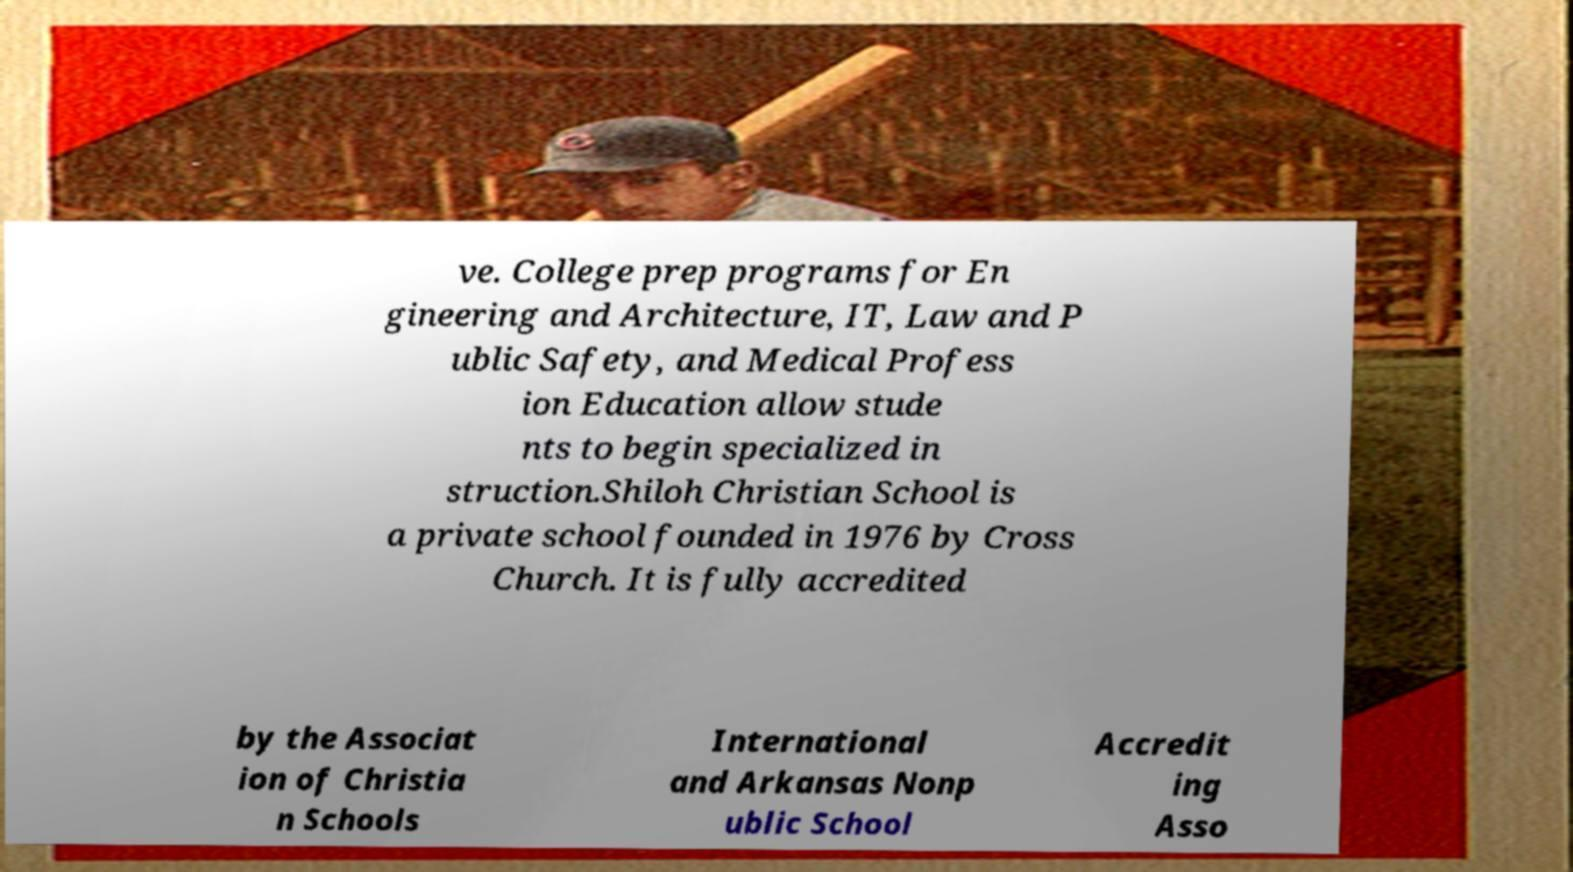Could you extract and type out the text from this image? ve. College prep programs for En gineering and Architecture, IT, Law and P ublic Safety, and Medical Profess ion Education allow stude nts to begin specialized in struction.Shiloh Christian School is a private school founded in 1976 by Cross Church. It is fully accredited by the Associat ion of Christia n Schools International and Arkansas Nonp ublic School Accredit ing Asso 